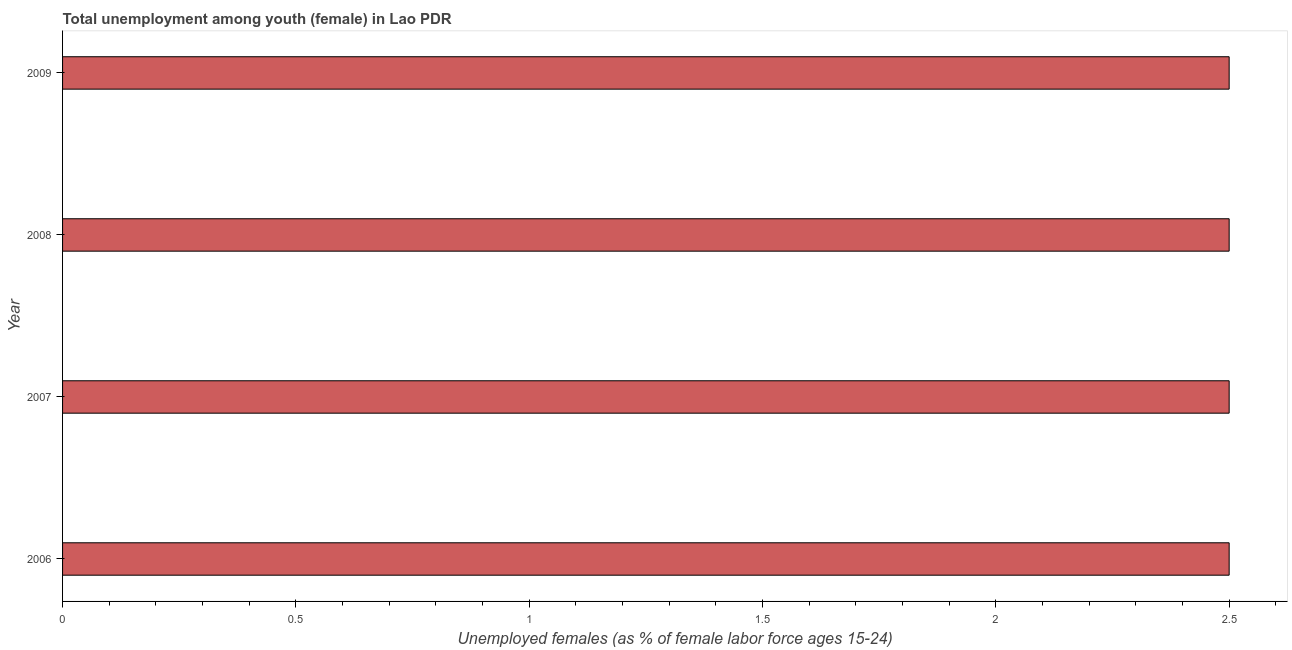Does the graph contain any zero values?
Ensure brevity in your answer.  No. Does the graph contain grids?
Give a very brief answer. No. What is the title of the graph?
Provide a succinct answer. Total unemployment among youth (female) in Lao PDR. What is the label or title of the X-axis?
Offer a very short reply. Unemployed females (as % of female labor force ages 15-24). What is the label or title of the Y-axis?
Give a very brief answer. Year. Across all years, what is the minimum unemployed female youth population?
Give a very brief answer. 2.5. In which year was the unemployed female youth population minimum?
Your answer should be very brief. 2006. What is the average unemployed female youth population per year?
Provide a succinct answer. 2.5. What is the ratio of the unemployed female youth population in 2007 to that in 2008?
Offer a terse response. 1. Is the unemployed female youth population in 2006 less than that in 2009?
Offer a very short reply. No. Is the difference between the unemployed female youth population in 2006 and 2009 greater than the difference between any two years?
Offer a terse response. Yes. What is the difference between the highest and the second highest unemployed female youth population?
Your answer should be compact. 0. Is the sum of the unemployed female youth population in 2006 and 2008 greater than the maximum unemployed female youth population across all years?
Keep it short and to the point. Yes. In how many years, is the unemployed female youth population greater than the average unemployed female youth population taken over all years?
Keep it short and to the point. 0. How many bars are there?
Offer a very short reply. 4. How many years are there in the graph?
Your answer should be very brief. 4. What is the difference between two consecutive major ticks on the X-axis?
Your answer should be very brief. 0.5. What is the Unemployed females (as % of female labor force ages 15-24) in 2007?
Offer a terse response. 2.5. What is the Unemployed females (as % of female labor force ages 15-24) in 2008?
Ensure brevity in your answer.  2.5. What is the Unemployed females (as % of female labor force ages 15-24) of 2009?
Your answer should be compact. 2.5. What is the difference between the Unemployed females (as % of female labor force ages 15-24) in 2006 and 2009?
Offer a very short reply. 0. What is the difference between the Unemployed females (as % of female labor force ages 15-24) in 2007 and 2008?
Keep it short and to the point. 0. What is the difference between the Unemployed females (as % of female labor force ages 15-24) in 2007 and 2009?
Provide a short and direct response. 0. What is the difference between the Unemployed females (as % of female labor force ages 15-24) in 2008 and 2009?
Your response must be concise. 0. What is the ratio of the Unemployed females (as % of female labor force ages 15-24) in 2006 to that in 2007?
Your answer should be very brief. 1. What is the ratio of the Unemployed females (as % of female labor force ages 15-24) in 2007 to that in 2008?
Keep it short and to the point. 1. 